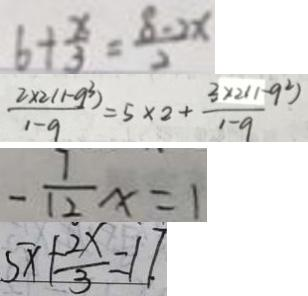<formula> <loc_0><loc_0><loc_500><loc_500>6 + \frac { x } { 3 } = \frac { 8 - 2 x } { 2 } 
 \frac { 2 \times 2 ( 1 - 9 ^ { 3 } ) } { 1 - 9 } = 5 \times 2 + \frac { 3 \times 2 ( 1 - 9 ^ { 2 } ) } { 1 - 9 } 
 - \frac { 7 } { 1 2 } x = 1 
 5 x + \frac { 2 x } { 3 } = 1 7 .</formula> 